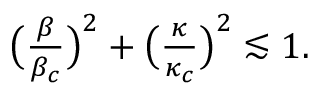<formula> <loc_0><loc_0><loc_500><loc_500>\begin{array} { r } { \left ( \frac { \beta } { \beta _ { c } } \right ) ^ { 2 } + \left ( \frac { \kappa } { \kappa _ { c } } \right ) ^ { 2 } \lesssim 1 . } \end{array}</formula> 